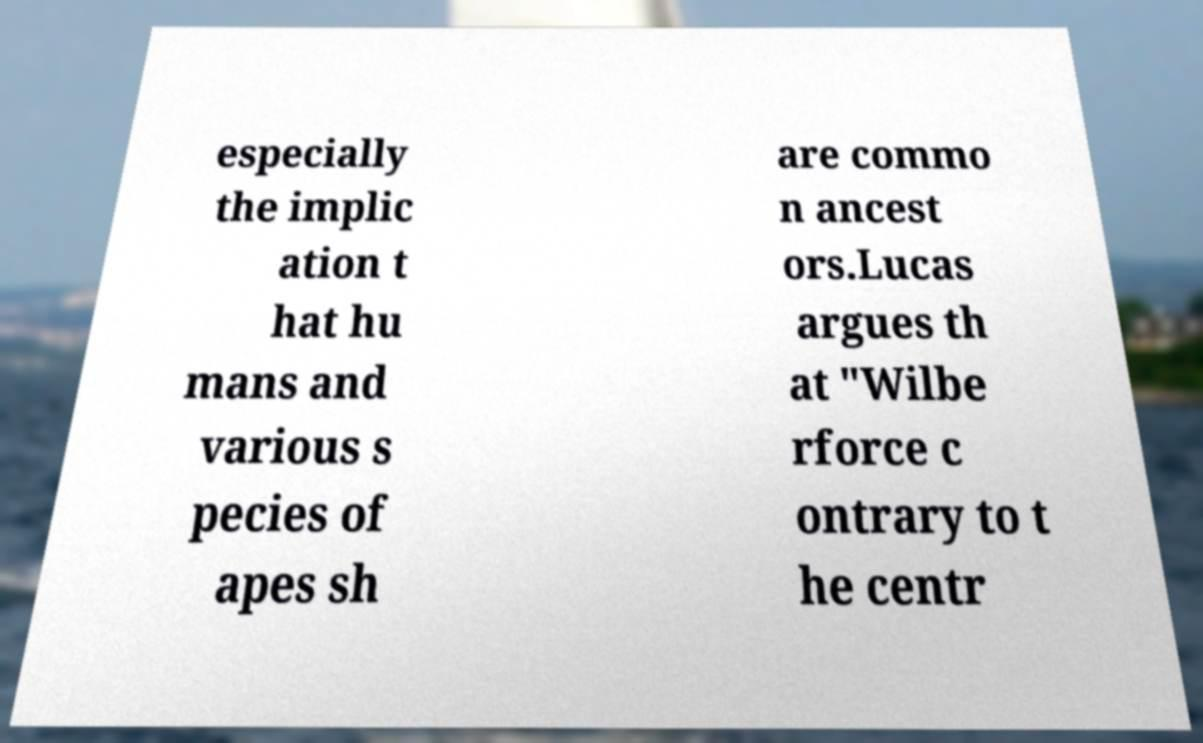Can you accurately transcribe the text from the provided image for me? especially the implic ation t hat hu mans and various s pecies of apes sh are commo n ancest ors.Lucas argues th at "Wilbe rforce c ontrary to t he centr 